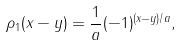Convert formula to latex. <formula><loc_0><loc_0><loc_500><loc_500>\rho _ { 1 } ( x - y ) = \frac { 1 } { a } ( - 1 ) ^ { ( x - y ) / a } ,</formula> 